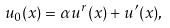<formula> <loc_0><loc_0><loc_500><loc_500>u _ { 0 } ( x ) = \alpha u ^ { r } ( x ) + u ^ { \prime } ( x ) ,</formula> 